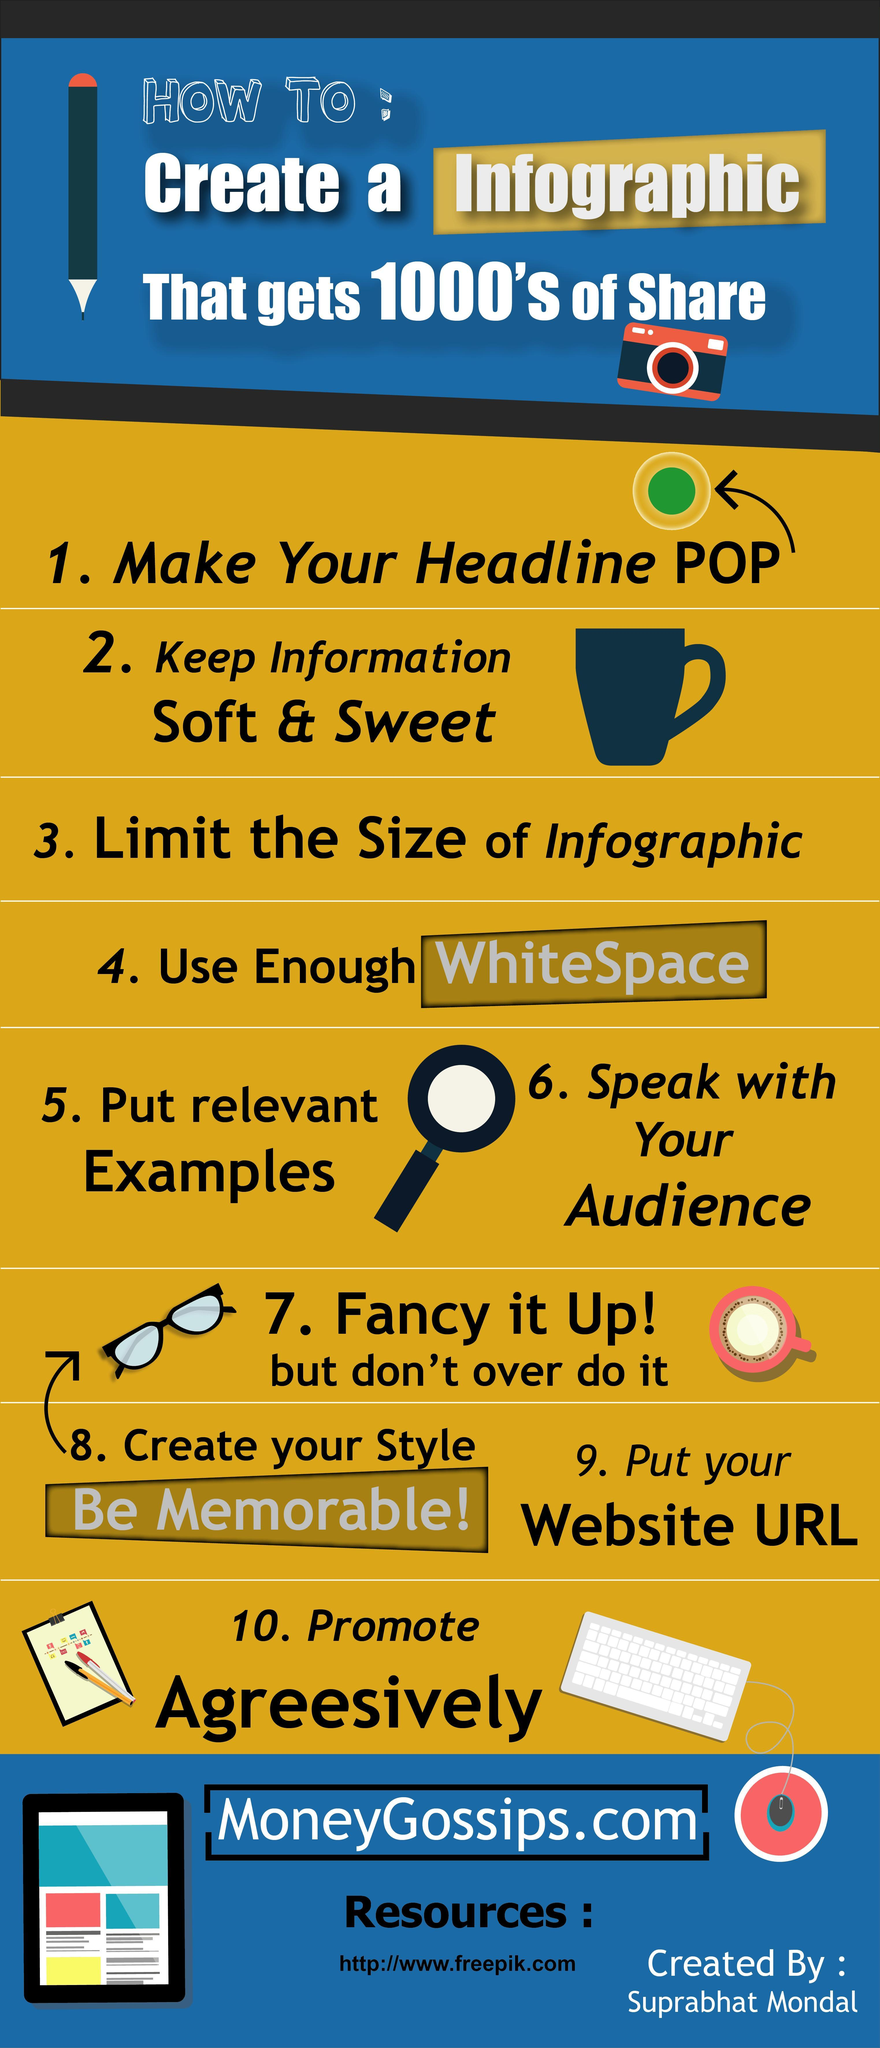What is the color of the cup shown in the infographic- red, green, blue, yellow?
Answer the question with a short phrase. blue 